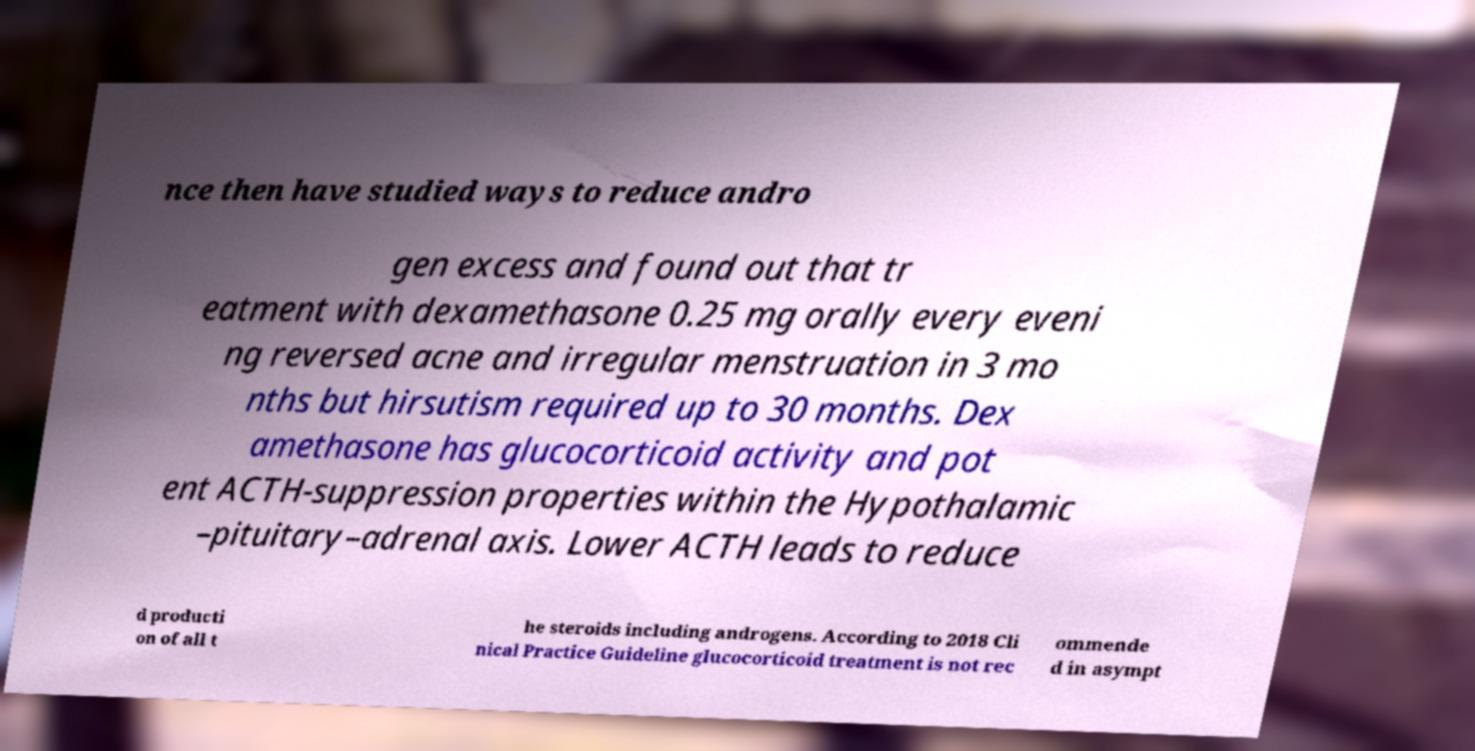For documentation purposes, I need the text within this image transcribed. Could you provide that? nce then have studied ways to reduce andro gen excess and found out that tr eatment with dexamethasone 0.25 mg orally every eveni ng reversed acne and irregular menstruation in 3 mo nths but hirsutism required up to 30 months. Dex amethasone has glucocorticoid activity and pot ent ACTH-suppression properties within the Hypothalamic –pituitary–adrenal axis. Lower ACTH leads to reduce d producti on of all t he steroids including androgens. According to 2018 Cli nical Practice Guideline glucocorticoid treatment is not rec ommende d in asympt 